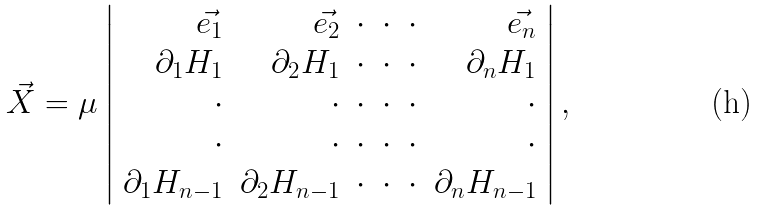Convert formula to latex. <formula><loc_0><loc_0><loc_500><loc_500>\vec { X } = \mu \left | \begin{array} { r r r r r r } \vec { e _ { 1 } } & \vec { e _ { 2 } } & \cdot & \cdot & \cdot & \vec { e _ { n } } \\ \partial _ { 1 } H _ { 1 } & \partial _ { 2 } H _ { 1 } & \cdot & \cdot & \cdot & \partial _ { n } H _ { 1 } \\ \cdot & \cdot & \cdot & \cdot & \cdot & \cdot \\ \cdot & \cdot & \cdot & \cdot & \cdot & \cdot \\ \partial _ { 1 } H _ { n - 1 } & \partial _ { 2 } H _ { n - 1 } & \cdot & \cdot & \cdot & \partial _ { n } H _ { n - 1 } \end{array} \right | ,</formula> 